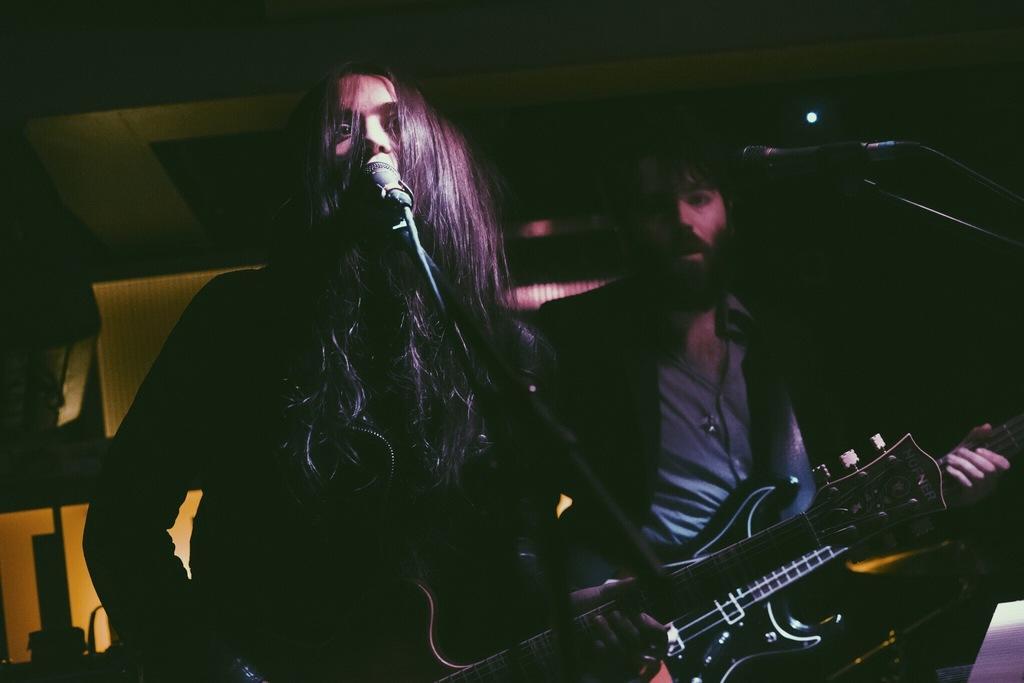In one or two sentences, can you explain what this image depicts? there are 2 people standing holding guitar. there are microphones present in front of them. 